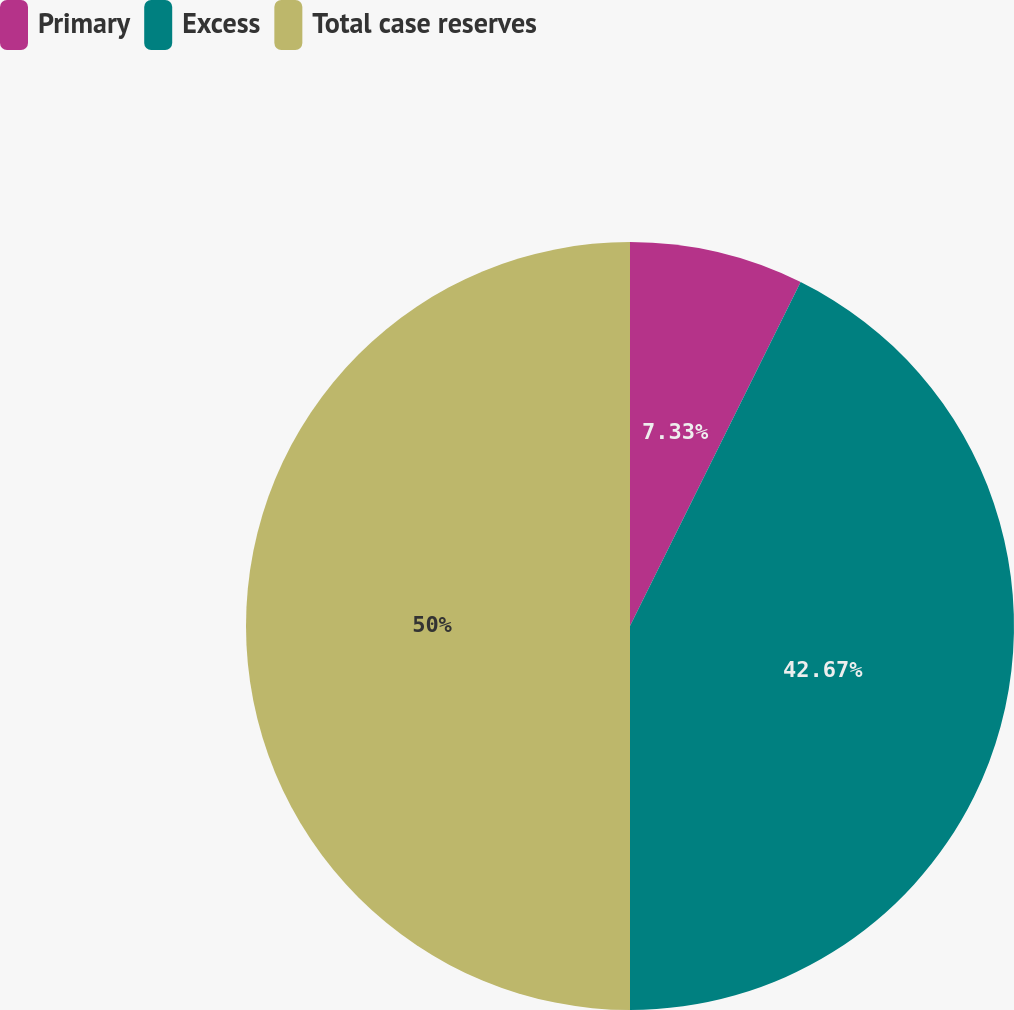Convert chart. <chart><loc_0><loc_0><loc_500><loc_500><pie_chart><fcel>Primary<fcel>Excess<fcel>Total case reserves<nl><fcel>7.33%<fcel>42.67%<fcel>50.0%<nl></chart> 